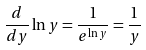Convert formula to latex. <formula><loc_0><loc_0><loc_500><loc_500>\frac { d } { d y } \ln y = \frac { 1 } { e ^ { \ln y } } = \frac { 1 } { y }</formula> 